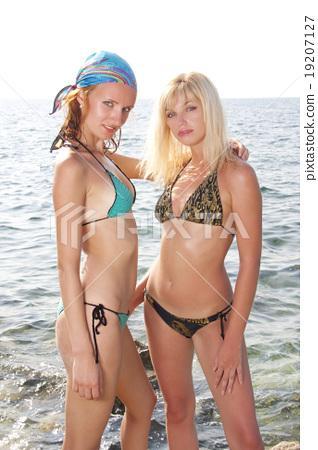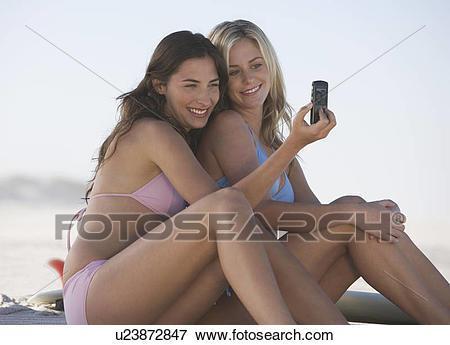The first image is the image on the left, the second image is the image on the right. Examine the images to the left and right. Is the description "A female is wearing a yellow bikini." accurate? Answer yes or no. No. The first image is the image on the left, the second image is the image on the right. Evaluate the accuracy of this statement regarding the images: "At least one woman has her hand on her hips.". Is it true? Answer yes or no. No. 